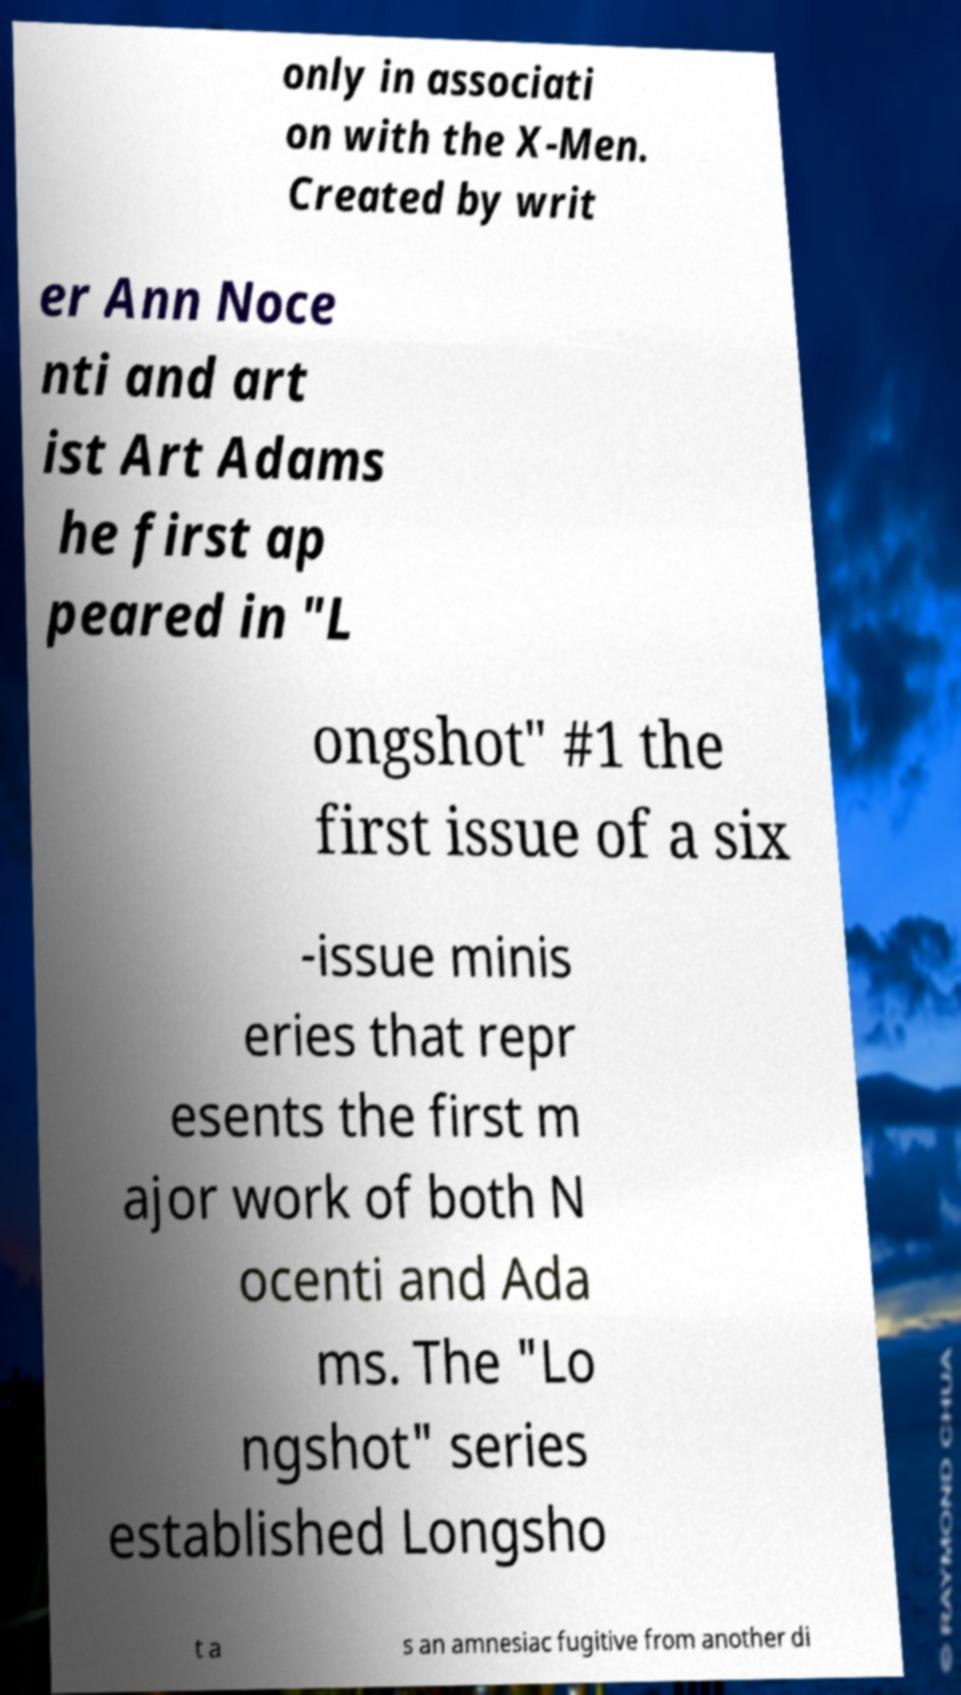Can you accurately transcribe the text from the provided image for me? only in associati on with the X-Men. Created by writ er Ann Noce nti and art ist Art Adams he first ap peared in "L ongshot" #1 the first issue of a six -issue minis eries that repr esents the first m ajor work of both N ocenti and Ada ms. The "Lo ngshot" series established Longsho t a s an amnesiac fugitive from another di 